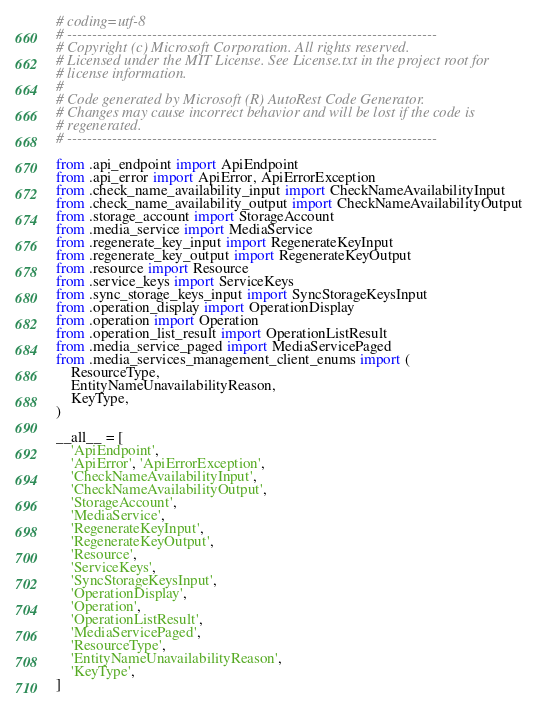<code> <loc_0><loc_0><loc_500><loc_500><_Python_># coding=utf-8
# --------------------------------------------------------------------------
# Copyright (c) Microsoft Corporation. All rights reserved.
# Licensed under the MIT License. See License.txt in the project root for
# license information.
#
# Code generated by Microsoft (R) AutoRest Code Generator.
# Changes may cause incorrect behavior and will be lost if the code is
# regenerated.
# --------------------------------------------------------------------------

from .api_endpoint import ApiEndpoint
from .api_error import ApiError, ApiErrorException
from .check_name_availability_input import CheckNameAvailabilityInput
from .check_name_availability_output import CheckNameAvailabilityOutput
from .storage_account import StorageAccount
from .media_service import MediaService
from .regenerate_key_input import RegenerateKeyInput
from .regenerate_key_output import RegenerateKeyOutput
from .resource import Resource
from .service_keys import ServiceKeys
from .sync_storage_keys_input import SyncStorageKeysInput
from .operation_display import OperationDisplay
from .operation import Operation
from .operation_list_result import OperationListResult
from .media_service_paged import MediaServicePaged
from .media_services_management_client_enums import (
    ResourceType,
    EntityNameUnavailabilityReason,
    KeyType,
)

__all__ = [
    'ApiEndpoint',
    'ApiError', 'ApiErrorException',
    'CheckNameAvailabilityInput',
    'CheckNameAvailabilityOutput',
    'StorageAccount',
    'MediaService',
    'RegenerateKeyInput',
    'RegenerateKeyOutput',
    'Resource',
    'ServiceKeys',
    'SyncStorageKeysInput',
    'OperationDisplay',
    'Operation',
    'OperationListResult',
    'MediaServicePaged',
    'ResourceType',
    'EntityNameUnavailabilityReason',
    'KeyType',
]
</code> 